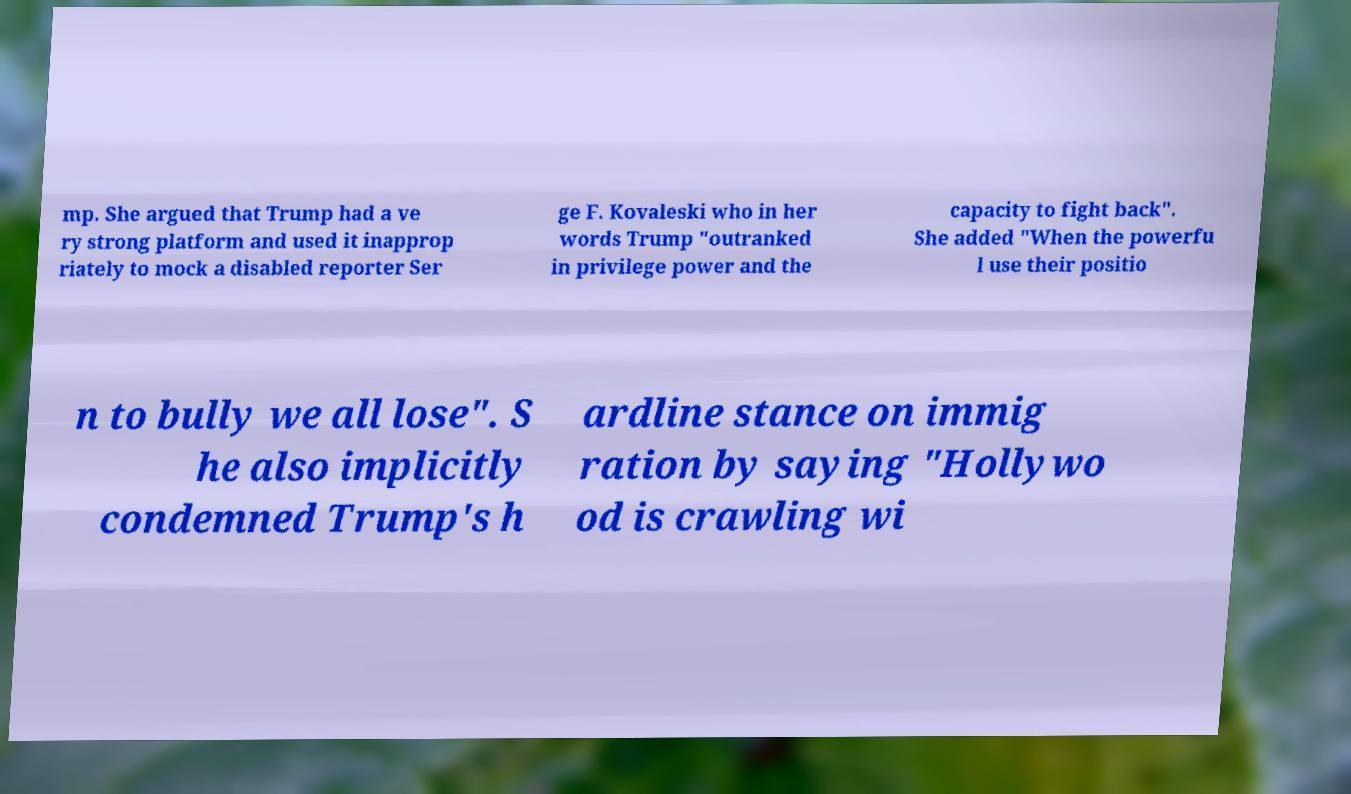Can you read and provide the text displayed in the image?This photo seems to have some interesting text. Can you extract and type it out for me? mp. She argued that Trump had a ve ry strong platform and used it inapprop riately to mock a disabled reporter Ser ge F. Kovaleski who in her words Trump "outranked in privilege power and the capacity to fight back". She added "When the powerfu l use their positio n to bully we all lose". S he also implicitly condemned Trump's h ardline stance on immig ration by saying "Hollywo od is crawling wi 